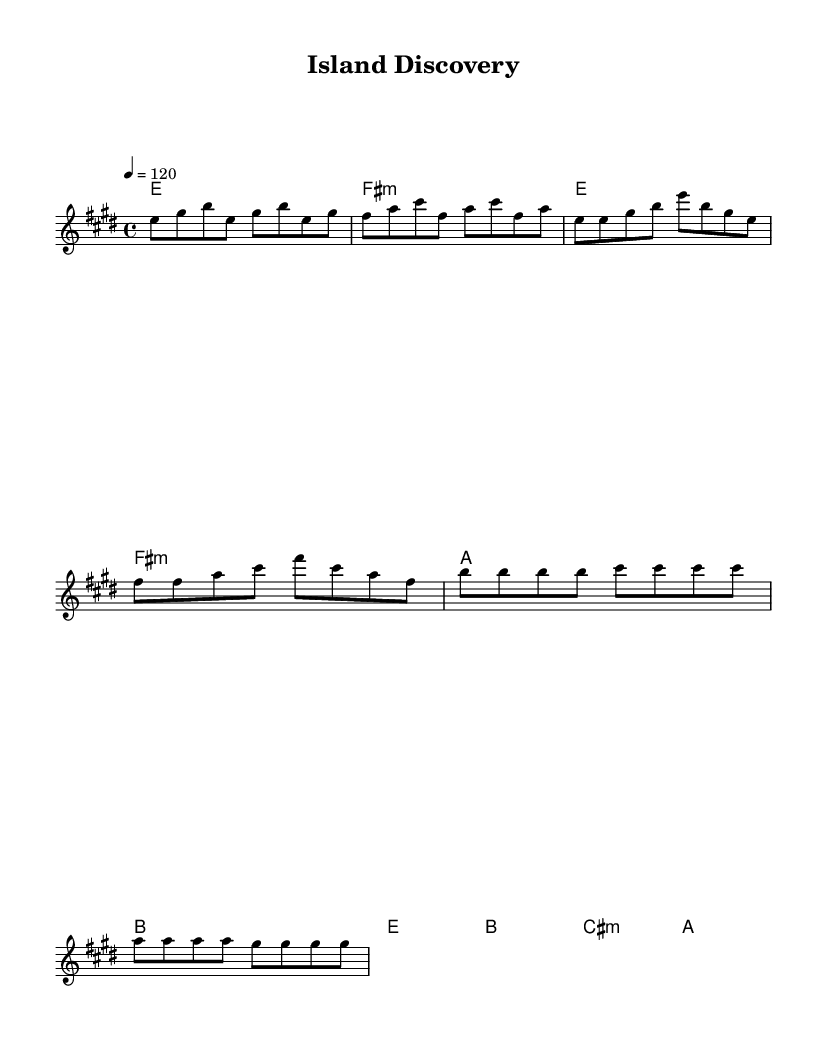What is the key signature of this music? The key signature is indicated by the sharp signs in the music notation. In this case, there are four sharps: F#, C#, G#, and D#. This indicates that the piece is in E major.
Answer: E major What is the time signature of the music? The time signature is shown at the beginning of the score, represented as 4/4. This means there are four beats in each measure and a quarter note receives one beat.
Answer: 4/4 What is the tempo marking for this piece? The tempo marking indicates how fast the piece should be played. In this score, it shows "4 = 120," meaning there are 120 quarter note beats per minute.
Answer: 120 How many measures are in the entire piece? To determine the total number of measures, one can count each distinct group of bars in the score. In this case, there are a total of 12 measures present.
Answer: 12 What type of harmonic progression is primarily used in the verse section? By examining the chord changes during the verse, they consist of E major, F# minor, A major, and B major followed sequentially. This suggests a common rock progression typically found in pop and rock music.
Answer: E, F# minor, A, B What is the main vocal melody range (starting and ending notes) in the chorus? The melody starts with B and ends with G# in the chorus. This indicates the vocal range utilized during this section for the lead.
Answer: B to G# What emotion or theme is suggested by the overall tempo and harmony of the piece? The upbeat tempo of 120 combined with major chords conveys a sense of energy and positivity, typical of rock anthems. It suggests feelings of adventure and exploration, resonating with the theme of island discovery.
Answer: Adventure 